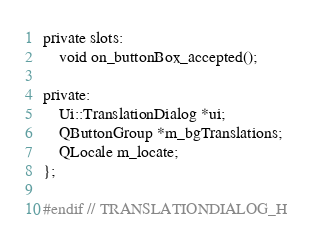Convert code to text. <code><loc_0><loc_0><loc_500><loc_500><_C_>private slots:
    void on_buttonBox_accepted();

private:
    Ui::TranslationDialog *ui;
    QButtonGroup *m_bgTranslations;
    QLocale m_locate;
};

#endif // TRANSLATIONDIALOG_H
</code> 